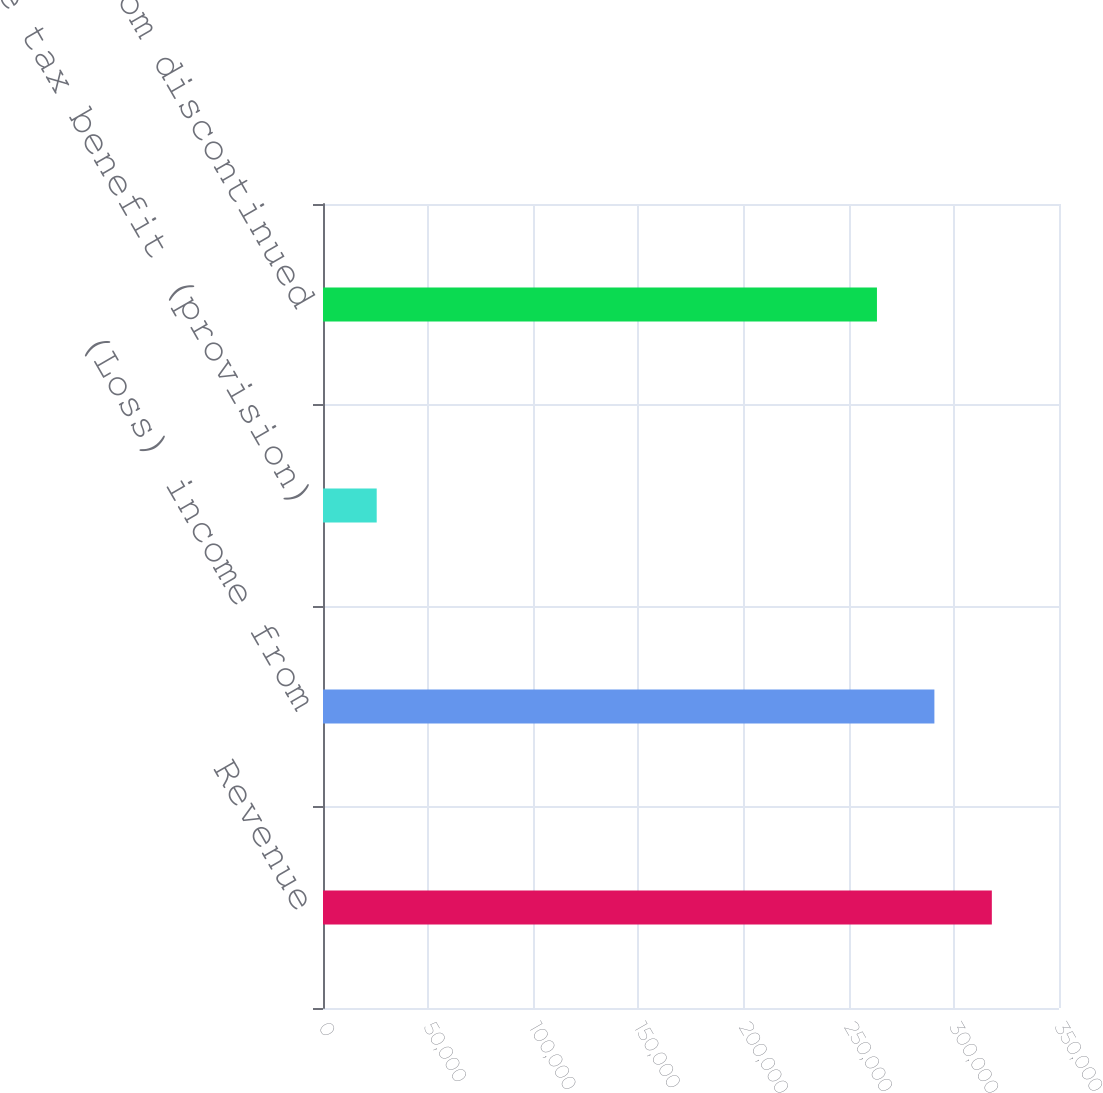<chart> <loc_0><loc_0><loc_500><loc_500><bar_chart><fcel>Revenue<fcel>(Loss) income from<fcel>Income tax benefit (provision)<fcel>Loss from discontinued<nl><fcel>318062<fcel>290744<fcel>25541<fcel>263427<nl></chart> 